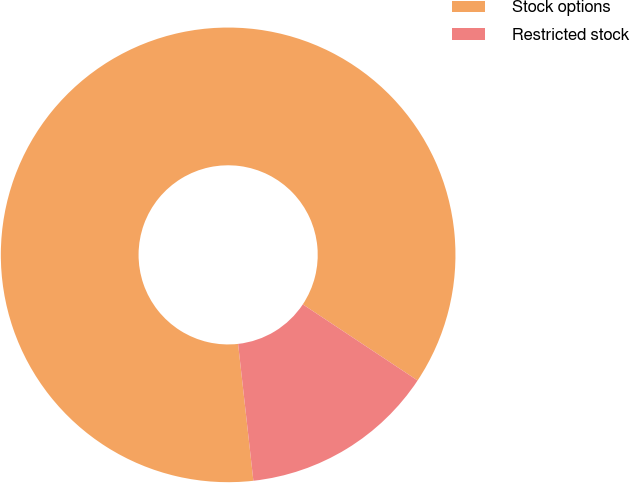Convert chart to OTSL. <chart><loc_0><loc_0><loc_500><loc_500><pie_chart><fcel>Stock options<fcel>Restricted stock<nl><fcel>86.09%<fcel>13.91%<nl></chart> 